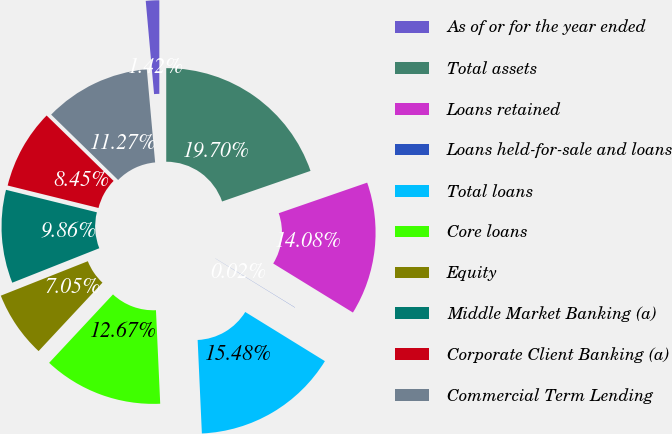Convert chart to OTSL. <chart><loc_0><loc_0><loc_500><loc_500><pie_chart><fcel>As of or for the year ended<fcel>Total assets<fcel>Loans retained<fcel>Loans held-for-sale and loans<fcel>Total loans<fcel>Core loans<fcel>Equity<fcel>Middle Market Banking (a)<fcel>Corporate Client Banking (a)<fcel>Commercial Term Lending<nl><fcel>1.42%<fcel>19.7%<fcel>14.08%<fcel>0.02%<fcel>15.48%<fcel>12.67%<fcel>7.05%<fcel>9.86%<fcel>8.45%<fcel>11.27%<nl></chart> 